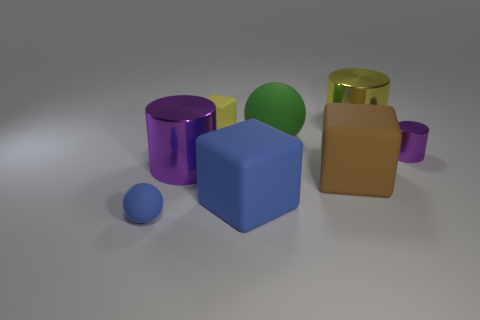Add 2 big cubes. How many objects exist? 10 Subtract all cubes. How many objects are left? 5 Subtract 0 purple cubes. How many objects are left? 8 Subtract all large brown matte cylinders. Subtract all tiny purple objects. How many objects are left? 7 Add 6 big purple metallic cylinders. How many big purple metallic cylinders are left? 7 Add 1 small matte cylinders. How many small matte cylinders exist? 1 